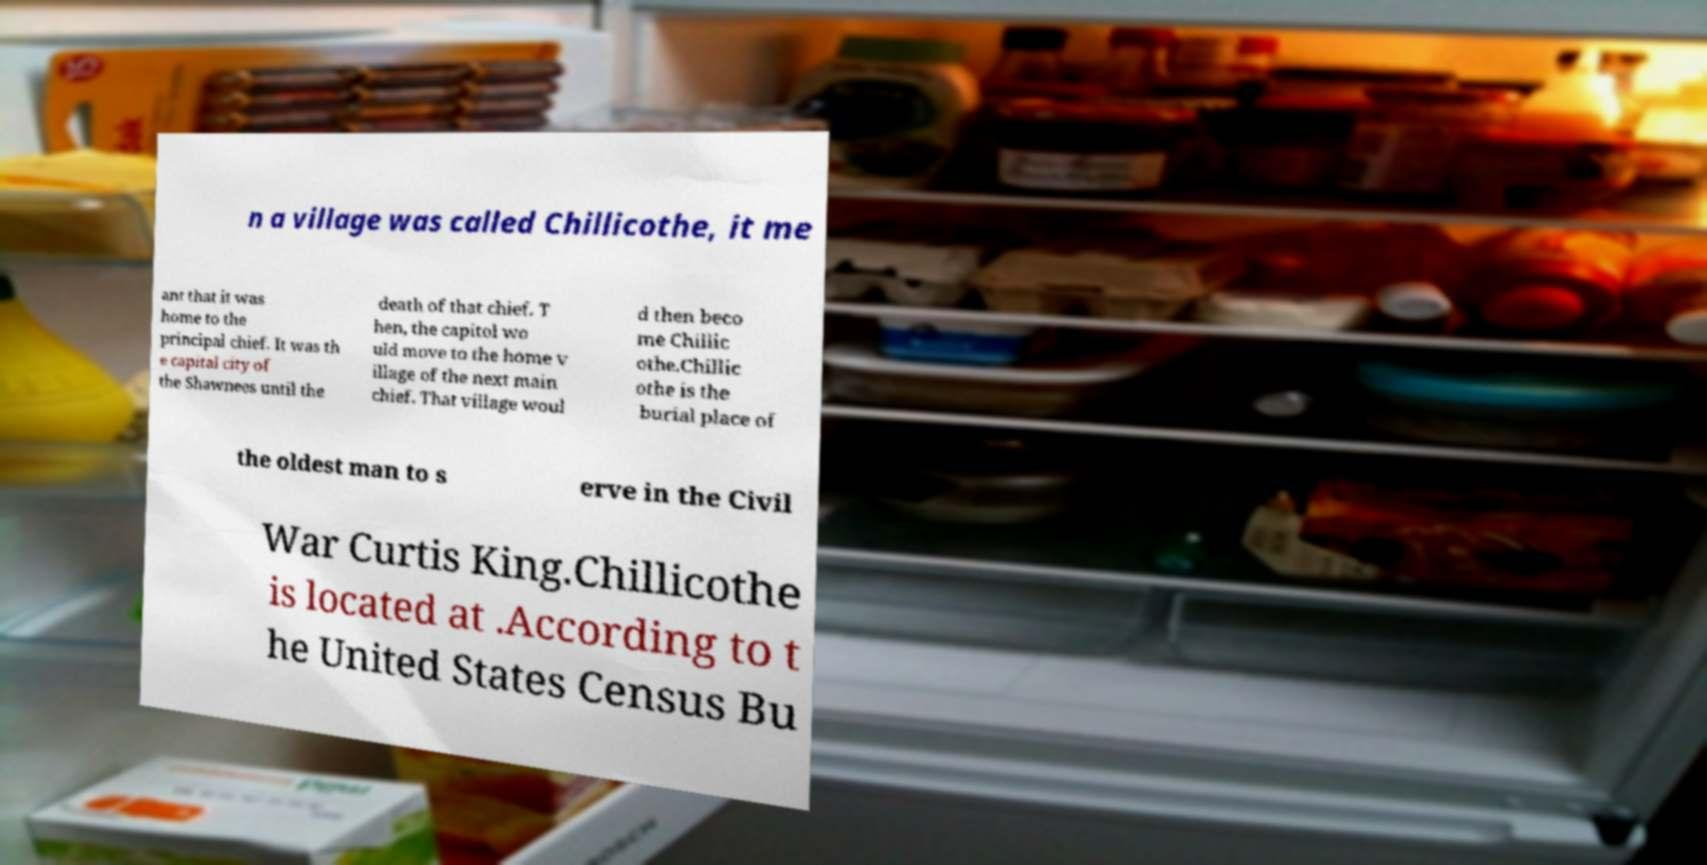Could you assist in decoding the text presented in this image and type it out clearly? n a village was called Chillicothe, it me ant that it was home to the principal chief. It was th e capital city of the Shawnees until the death of that chief. T hen, the capitol wo uld move to the home v illage of the next main chief. That village woul d then beco me Chillic othe.Chillic othe is the burial place of the oldest man to s erve in the Civil War Curtis King.Chillicothe is located at .According to t he United States Census Bu 